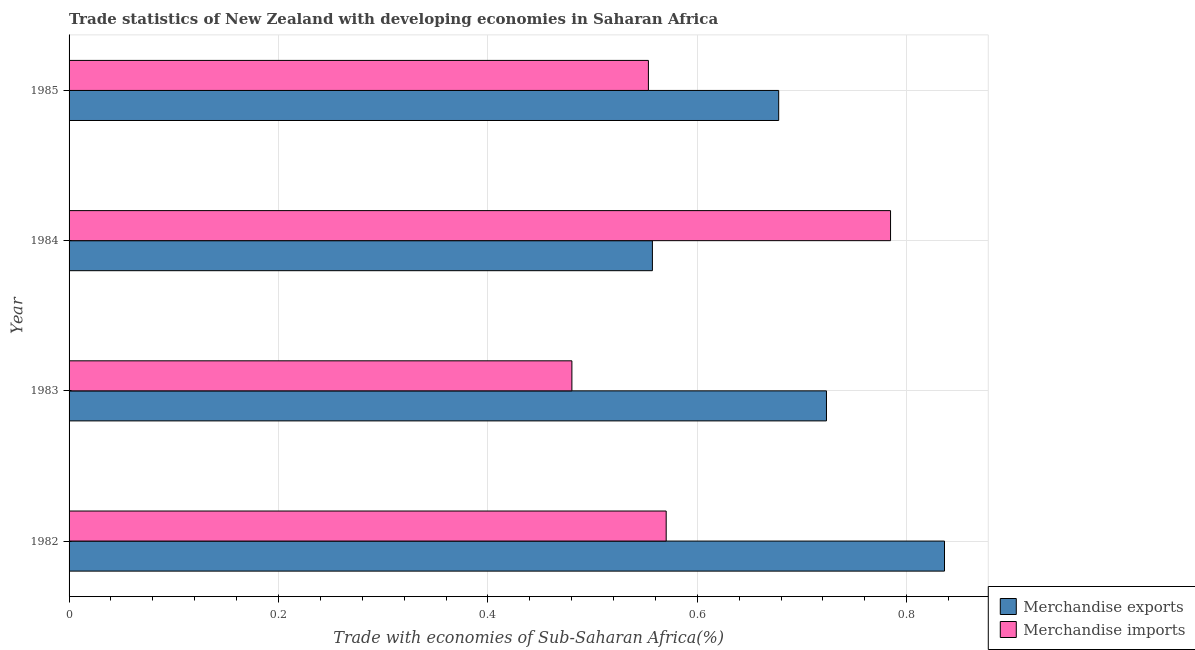How many different coloured bars are there?
Your response must be concise. 2. In how many cases, is the number of bars for a given year not equal to the number of legend labels?
Offer a terse response. 0. What is the merchandise imports in 1985?
Your response must be concise. 0.55. Across all years, what is the maximum merchandise imports?
Your answer should be very brief. 0.78. Across all years, what is the minimum merchandise exports?
Your answer should be very brief. 0.56. What is the total merchandise exports in the graph?
Your response must be concise. 2.79. What is the difference between the merchandise exports in 1983 and that in 1985?
Your answer should be compact. 0.05. What is the difference between the merchandise exports in 1985 and the merchandise imports in 1983?
Provide a succinct answer. 0.2. What is the average merchandise exports per year?
Your answer should be very brief. 0.7. In the year 1982, what is the difference between the merchandise imports and merchandise exports?
Provide a succinct answer. -0.27. What is the ratio of the merchandise imports in 1982 to that in 1985?
Offer a terse response. 1.03. Is the merchandise exports in 1982 less than that in 1985?
Give a very brief answer. No. What is the difference between the highest and the second highest merchandise exports?
Offer a terse response. 0.11. What is the difference between the highest and the lowest merchandise imports?
Offer a terse response. 0.3. In how many years, is the merchandise exports greater than the average merchandise exports taken over all years?
Your response must be concise. 2. Is the sum of the merchandise exports in 1983 and 1984 greater than the maximum merchandise imports across all years?
Your answer should be compact. Yes. What does the 2nd bar from the top in 1985 represents?
Provide a short and direct response. Merchandise exports. What does the 1st bar from the bottom in 1982 represents?
Give a very brief answer. Merchandise exports. How many bars are there?
Make the answer very short. 8. What is the title of the graph?
Your answer should be very brief. Trade statistics of New Zealand with developing economies in Saharan Africa. What is the label or title of the X-axis?
Your answer should be compact. Trade with economies of Sub-Saharan Africa(%). What is the Trade with economies of Sub-Saharan Africa(%) of Merchandise exports in 1982?
Provide a short and direct response. 0.84. What is the Trade with economies of Sub-Saharan Africa(%) in Merchandise imports in 1982?
Your answer should be very brief. 0.57. What is the Trade with economies of Sub-Saharan Africa(%) of Merchandise exports in 1983?
Make the answer very short. 0.72. What is the Trade with economies of Sub-Saharan Africa(%) in Merchandise imports in 1983?
Keep it short and to the point. 0.48. What is the Trade with economies of Sub-Saharan Africa(%) in Merchandise exports in 1984?
Make the answer very short. 0.56. What is the Trade with economies of Sub-Saharan Africa(%) of Merchandise imports in 1984?
Your answer should be very brief. 0.78. What is the Trade with economies of Sub-Saharan Africa(%) in Merchandise exports in 1985?
Make the answer very short. 0.68. What is the Trade with economies of Sub-Saharan Africa(%) of Merchandise imports in 1985?
Ensure brevity in your answer.  0.55. Across all years, what is the maximum Trade with economies of Sub-Saharan Africa(%) in Merchandise exports?
Make the answer very short. 0.84. Across all years, what is the maximum Trade with economies of Sub-Saharan Africa(%) of Merchandise imports?
Keep it short and to the point. 0.78. Across all years, what is the minimum Trade with economies of Sub-Saharan Africa(%) of Merchandise exports?
Offer a terse response. 0.56. Across all years, what is the minimum Trade with economies of Sub-Saharan Africa(%) of Merchandise imports?
Give a very brief answer. 0.48. What is the total Trade with economies of Sub-Saharan Africa(%) in Merchandise exports in the graph?
Your response must be concise. 2.79. What is the total Trade with economies of Sub-Saharan Africa(%) in Merchandise imports in the graph?
Keep it short and to the point. 2.39. What is the difference between the Trade with economies of Sub-Saharan Africa(%) of Merchandise exports in 1982 and that in 1983?
Keep it short and to the point. 0.11. What is the difference between the Trade with economies of Sub-Saharan Africa(%) in Merchandise imports in 1982 and that in 1983?
Your response must be concise. 0.09. What is the difference between the Trade with economies of Sub-Saharan Africa(%) in Merchandise exports in 1982 and that in 1984?
Ensure brevity in your answer.  0.28. What is the difference between the Trade with economies of Sub-Saharan Africa(%) in Merchandise imports in 1982 and that in 1984?
Your answer should be compact. -0.21. What is the difference between the Trade with economies of Sub-Saharan Africa(%) in Merchandise exports in 1982 and that in 1985?
Make the answer very short. 0.16. What is the difference between the Trade with economies of Sub-Saharan Africa(%) of Merchandise imports in 1982 and that in 1985?
Ensure brevity in your answer.  0.02. What is the difference between the Trade with economies of Sub-Saharan Africa(%) of Merchandise exports in 1983 and that in 1984?
Ensure brevity in your answer.  0.17. What is the difference between the Trade with economies of Sub-Saharan Africa(%) of Merchandise imports in 1983 and that in 1984?
Offer a very short reply. -0.3. What is the difference between the Trade with economies of Sub-Saharan Africa(%) in Merchandise exports in 1983 and that in 1985?
Offer a very short reply. 0.05. What is the difference between the Trade with economies of Sub-Saharan Africa(%) of Merchandise imports in 1983 and that in 1985?
Your answer should be very brief. -0.07. What is the difference between the Trade with economies of Sub-Saharan Africa(%) in Merchandise exports in 1984 and that in 1985?
Your answer should be compact. -0.12. What is the difference between the Trade with economies of Sub-Saharan Africa(%) of Merchandise imports in 1984 and that in 1985?
Your response must be concise. 0.23. What is the difference between the Trade with economies of Sub-Saharan Africa(%) in Merchandise exports in 1982 and the Trade with economies of Sub-Saharan Africa(%) in Merchandise imports in 1983?
Make the answer very short. 0.36. What is the difference between the Trade with economies of Sub-Saharan Africa(%) in Merchandise exports in 1982 and the Trade with economies of Sub-Saharan Africa(%) in Merchandise imports in 1984?
Provide a short and direct response. 0.05. What is the difference between the Trade with economies of Sub-Saharan Africa(%) in Merchandise exports in 1982 and the Trade with economies of Sub-Saharan Africa(%) in Merchandise imports in 1985?
Your answer should be very brief. 0.28. What is the difference between the Trade with economies of Sub-Saharan Africa(%) in Merchandise exports in 1983 and the Trade with economies of Sub-Saharan Africa(%) in Merchandise imports in 1984?
Provide a short and direct response. -0.06. What is the difference between the Trade with economies of Sub-Saharan Africa(%) in Merchandise exports in 1983 and the Trade with economies of Sub-Saharan Africa(%) in Merchandise imports in 1985?
Give a very brief answer. 0.17. What is the difference between the Trade with economies of Sub-Saharan Africa(%) in Merchandise exports in 1984 and the Trade with economies of Sub-Saharan Africa(%) in Merchandise imports in 1985?
Ensure brevity in your answer.  0. What is the average Trade with economies of Sub-Saharan Africa(%) of Merchandise exports per year?
Make the answer very short. 0.7. What is the average Trade with economies of Sub-Saharan Africa(%) in Merchandise imports per year?
Your response must be concise. 0.6. In the year 1982, what is the difference between the Trade with economies of Sub-Saharan Africa(%) of Merchandise exports and Trade with economies of Sub-Saharan Africa(%) of Merchandise imports?
Offer a very short reply. 0.27. In the year 1983, what is the difference between the Trade with economies of Sub-Saharan Africa(%) in Merchandise exports and Trade with economies of Sub-Saharan Africa(%) in Merchandise imports?
Offer a terse response. 0.24. In the year 1984, what is the difference between the Trade with economies of Sub-Saharan Africa(%) of Merchandise exports and Trade with economies of Sub-Saharan Africa(%) of Merchandise imports?
Make the answer very short. -0.23. In the year 1985, what is the difference between the Trade with economies of Sub-Saharan Africa(%) in Merchandise exports and Trade with economies of Sub-Saharan Africa(%) in Merchandise imports?
Give a very brief answer. 0.12. What is the ratio of the Trade with economies of Sub-Saharan Africa(%) of Merchandise exports in 1982 to that in 1983?
Your answer should be very brief. 1.16. What is the ratio of the Trade with economies of Sub-Saharan Africa(%) of Merchandise imports in 1982 to that in 1983?
Your answer should be very brief. 1.19. What is the ratio of the Trade with economies of Sub-Saharan Africa(%) of Merchandise exports in 1982 to that in 1984?
Make the answer very short. 1.5. What is the ratio of the Trade with economies of Sub-Saharan Africa(%) of Merchandise imports in 1982 to that in 1984?
Provide a short and direct response. 0.73. What is the ratio of the Trade with economies of Sub-Saharan Africa(%) in Merchandise exports in 1982 to that in 1985?
Give a very brief answer. 1.23. What is the ratio of the Trade with economies of Sub-Saharan Africa(%) of Merchandise imports in 1982 to that in 1985?
Your answer should be compact. 1.03. What is the ratio of the Trade with economies of Sub-Saharan Africa(%) in Merchandise exports in 1983 to that in 1984?
Your response must be concise. 1.3. What is the ratio of the Trade with economies of Sub-Saharan Africa(%) of Merchandise imports in 1983 to that in 1984?
Give a very brief answer. 0.61. What is the ratio of the Trade with economies of Sub-Saharan Africa(%) of Merchandise exports in 1983 to that in 1985?
Your response must be concise. 1.07. What is the ratio of the Trade with economies of Sub-Saharan Africa(%) of Merchandise imports in 1983 to that in 1985?
Give a very brief answer. 0.87. What is the ratio of the Trade with economies of Sub-Saharan Africa(%) in Merchandise exports in 1984 to that in 1985?
Your response must be concise. 0.82. What is the ratio of the Trade with economies of Sub-Saharan Africa(%) of Merchandise imports in 1984 to that in 1985?
Offer a terse response. 1.42. What is the difference between the highest and the second highest Trade with economies of Sub-Saharan Africa(%) of Merchandise exports?
Keep it short and to the point. 0.11. What is the difference between the highest and the second highest Trade with economies of Sub-Saharan Africa(%) of Merchandise imports?
Make the answer very short. 0.21. What is the difference between the highest and the lowest Trade with economies of Sub-Saharan Africa(%) of Merchandise exports?
Offer a very short reply. 0.28. What is the difference between the highest and the lowest Trade with economies of Sub-Saharan Africa(%) in Merchandise imports?
Your response must be concise. 0.3. 